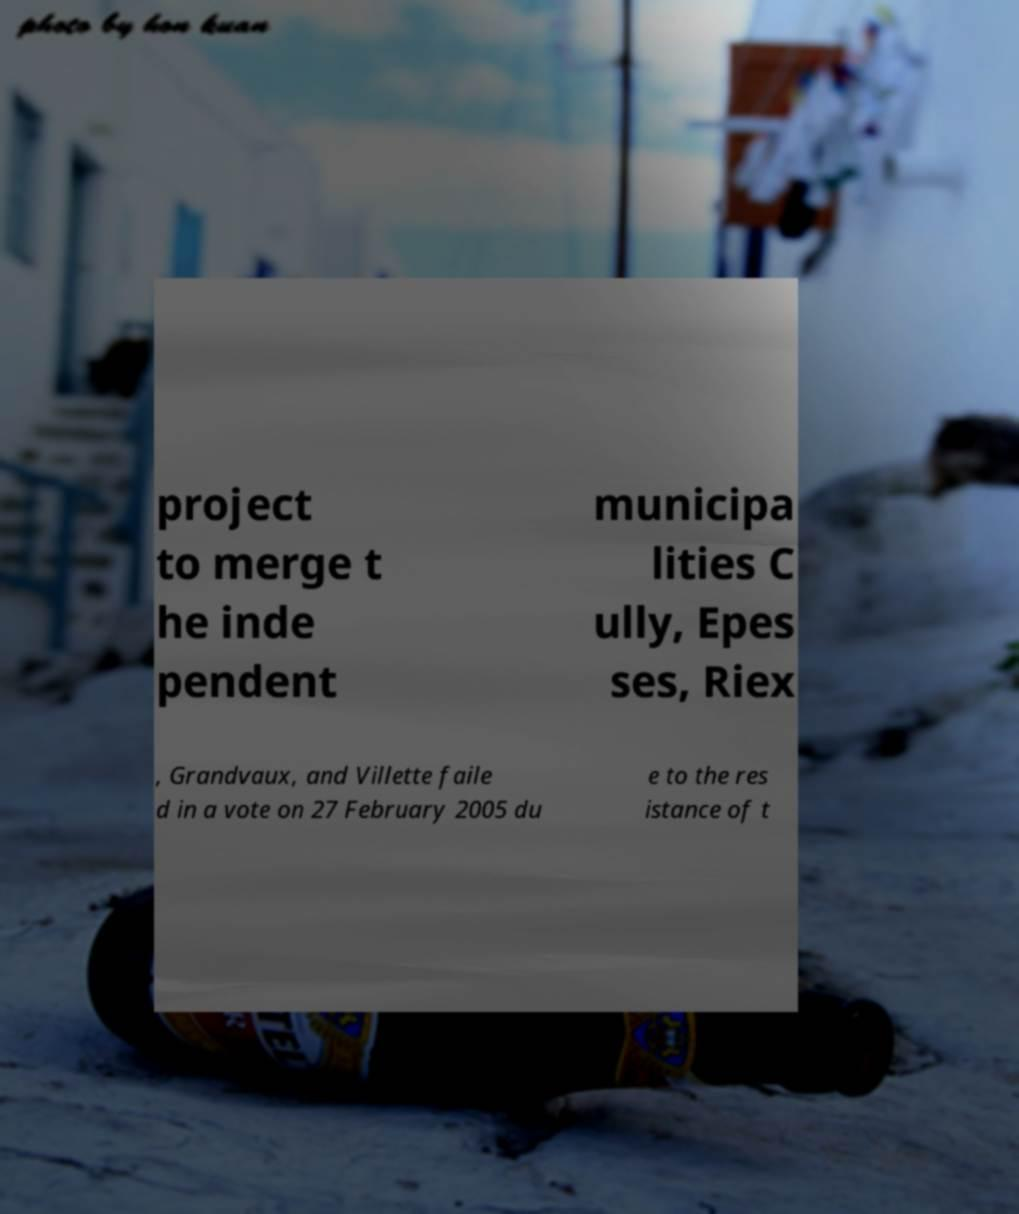Please identify and transcribe the text found in this image. project to merge t he inde pendent municipa lities C ully, Epes ses, Riex , Grandvaux, and Villette faile d in a vote on 27 February 2005 du e to the res istance of t 